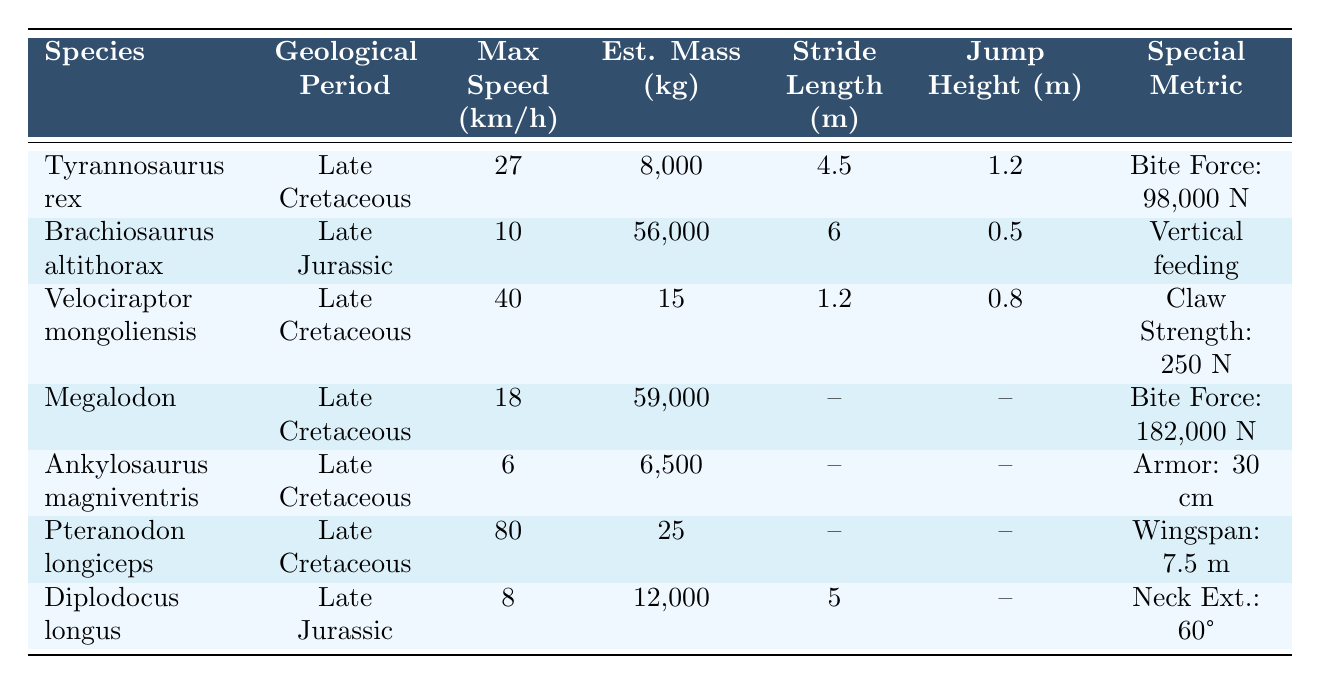What is the maximum speed of Velociraptor mongoliensis? The maximum speed for Velociraptor mongoliensis is found directly in the table under the "Max Speed (km/h)" column. It shows 40 km/h.
Answer: 40 km/h Which species has the highest estimated mass, and what is that mass? By inspecting the "Est. Mass (kg)" column, Brachiosaurus altithorax has the highest mass listed, which is 56,000 kg.
Answer: Brachiosaurus altithorax, 56,000 kg What is the average maximum speed of the species in the Late Cretaceous? The maximum speeds of Late Cretaceous species are Tyrannosaurus rex (27), Velociraptor mongoliensis (40), Megalodon (18), Ankylosaurus magniventris (6), and Pteranodon longiceps (80). Adding these gives 171 km/h. Dividing by the number of species (5) gives an average speed of 171/5 = 34.2 km/h.
Answer: 34.2 km/h Is the bite force of Tyrannosaurus rex greater than that of Megalodon? The bite force for Tyrannosaurus rex is 98,000 N, while for Megalodon, it is 182,000 N. Since 98,000 is less than 182,000, the statement is false.
Answer: No How does the maximum speed of Brachiosaurus altithorax compare to that of Diplodocus longus? Brachiosaurus altithorax has a maximum speed of 10 km/h, and Diplodocus longus has a maximum speed of 8 km/h. Comparing these values, 10 km/h is greater than 8 km/h.
Answer: Brachiosaurus altithorax is faster Which species has a jump height of more than 1 meter? Reviewing the "Jump Height (m)" column, only Tyrannosaurus rex has a jump height of 1.2 m, which is greater than 1 m. The other species listed have lower jump heights or none recorded.
Answer: Tyrannosaurus rex What percentage of the estimated mass of Velociraptor mongoliensis is the bite force of Tyrannosaurus rex? The estimated mass of Velociraptor mongoliensis is 15 kg, and the bite force of Tyrannosaurus rex is 98,000 N. To find the percentage, we calculate (98,000/15) * 100, which is 653,333.33%.
Answer: 653,333.33% Are there any species listed that have a stride length reported? Looking at the "Stride Length (m)" column, Tyrannosaurus rex, Brachiosaurus altithorax, and Diplodocus longus have stride lengths reported while the others do not. This indicates the answer is affirmative.
Answer: Yes, three species 